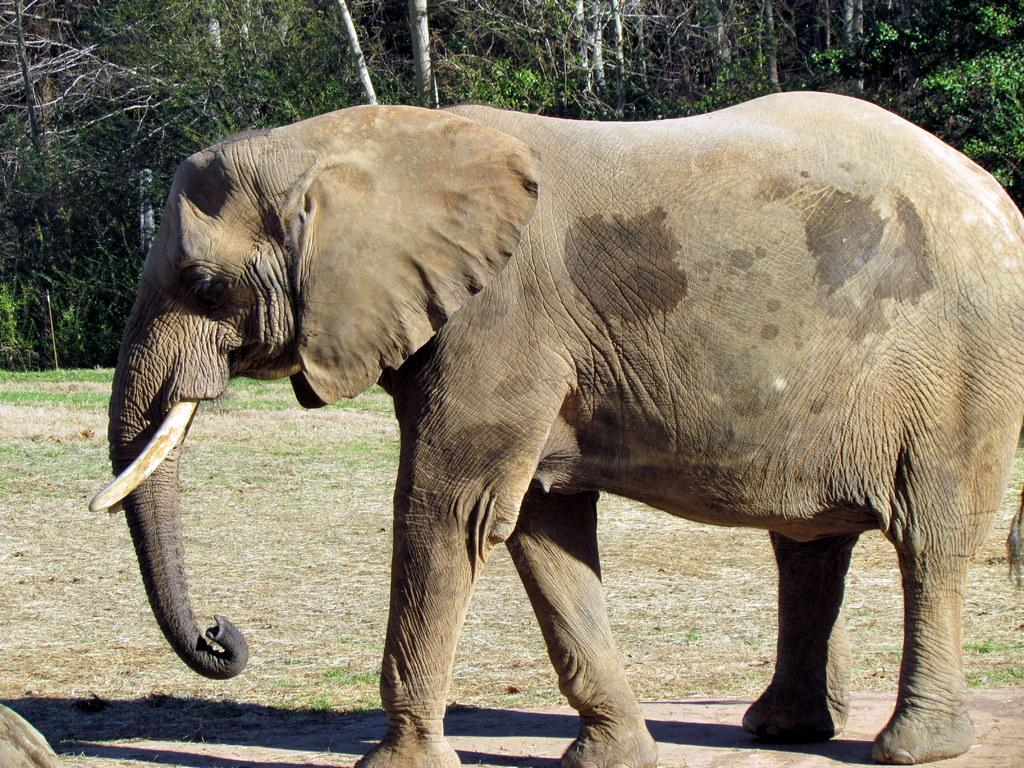What animal is the main subject of the image? There is an elephant in the image. Where is the elephant located in the image? The elephant is on the ground. What can be seen in the background of the image? There are trees in the background of the image. How does the elephant join the group of animals on the trail in the image? There is no group of animals or trail present in the image; it only features an elephant on the ground with trees in the background. 